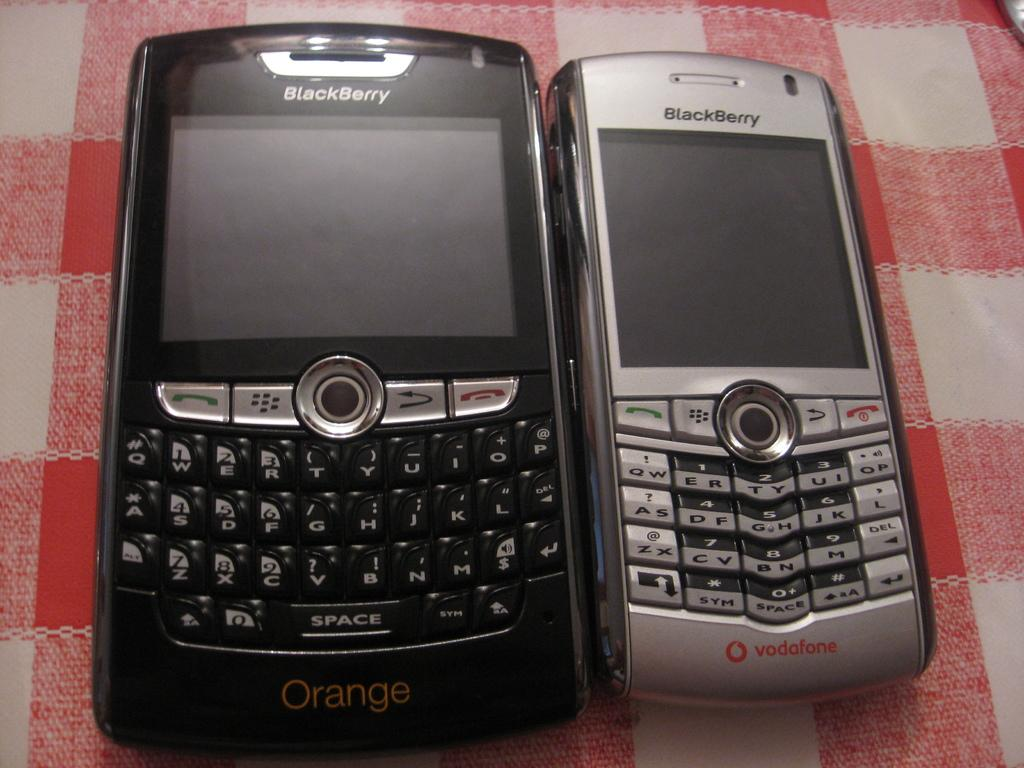<image>
Share a concise interpretation of the image provided. The black and silver cell phones here are Blackberry 